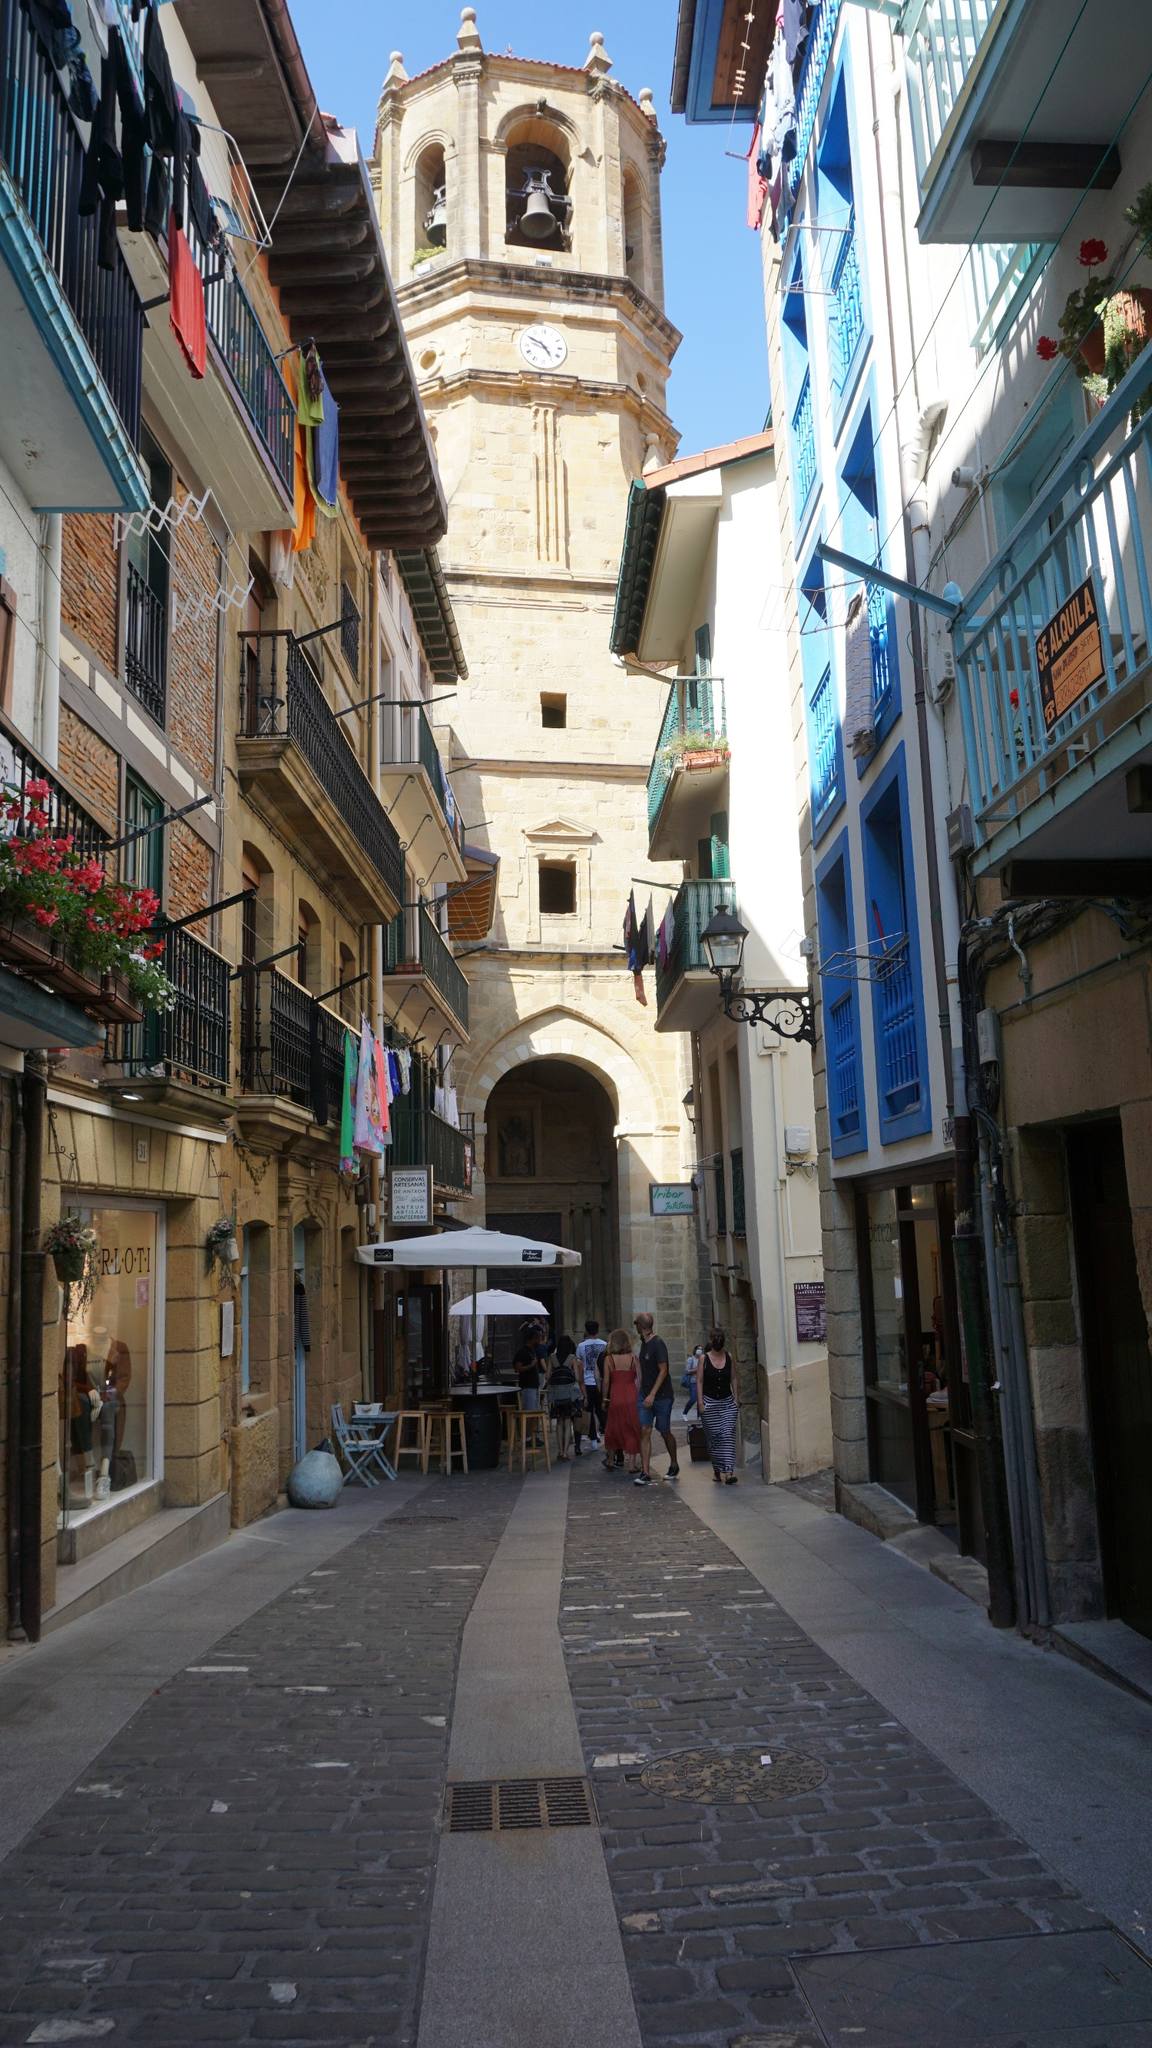What is this photo about'?
 The image captures a charming scene from a European town. A narrow cobblestone street, reminiscent of times gone by, stretches out before the viewer. The street is flanked by buildings painted in a variety of vibrant colors, their balconies adorned with blooming flower boxes that add a touch of nature to the urban landscape.

The buildings, with their traditional architecture, create a sense of depth and perspective, leading the viewer's eye towards the background of the image. There, a tall clock tower stands proudly against the sky. The tower, equipped with a bell and a flag, is a distinctive feature of the town, suggesting its importance to the local community.

The image is taken from a low angle, looking up towards the clock tower. This perspective enhances the grandeur of the tower and provides a unique viewpoint of the street and buildings. The overall composition of the image beautifully encapsulates the charm and character of this European town. 

As for the specific landmark, I'm afraid I couldn't find any information related to the identifier "sa_17154". It might be helpful to have more context or details about the landmark. 